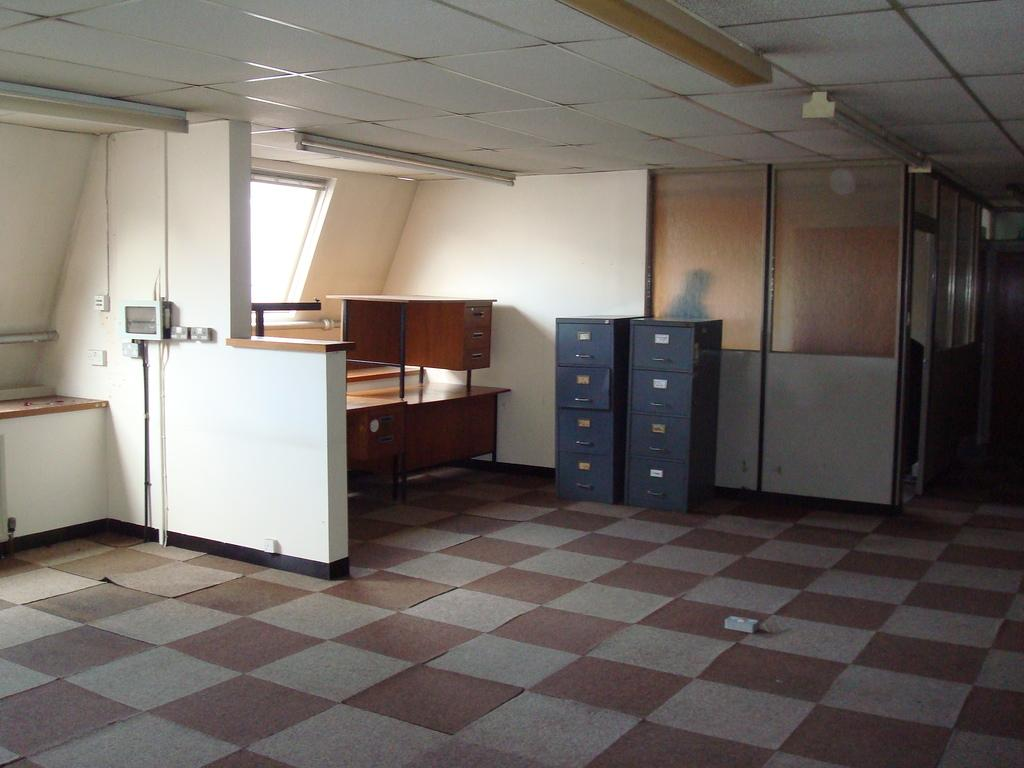What can be found in the center of the image? There are racks and tables in the center of the image. What is located on the left side of the image? There is a switch board on the left side of the image. What can be seen in the background of the image? There is a wall and glass in the background of the image. What type of surface is visible in the image? There is a floor visible in the image. Can you tell me how many pears are on the racks in the image? There are no pears present in the image; it features racks and tables. Is your sister helping to set up the switch board in the image? There is no reference to a sister or any people in the image, so it is not possible to answer that question. 